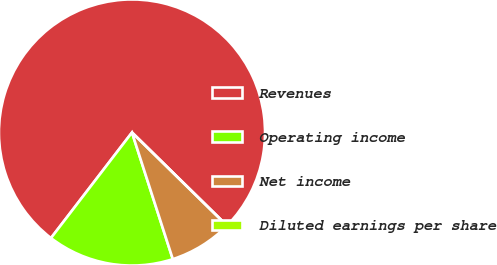<chart> <loc_0><loc_0><loc_500><loc_500><pie_chart><fcel>Revenues<fcel>Operating income<fcel>Net income<fcel>Diluted earnings per share<nl><fcel>76.92%<fcel>15.38%<fcel>7.69%<fcel>0.0%<nl></chart> 